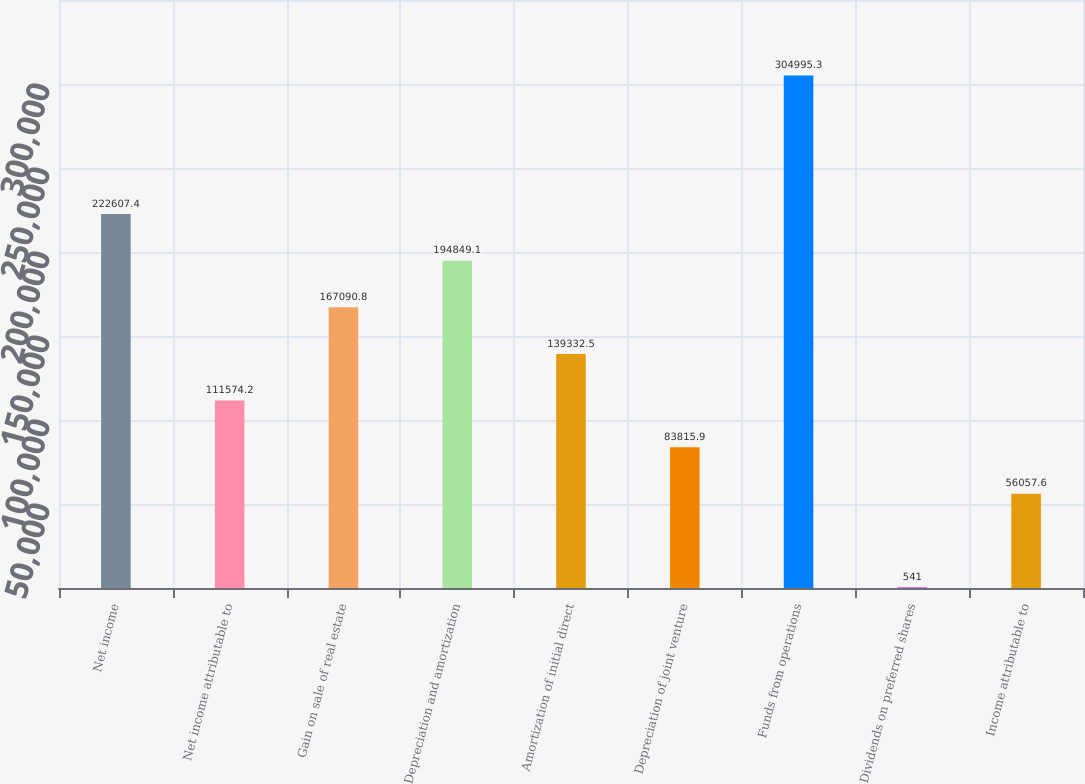Convert chart. <chart><loc_0><loc_0><loc_500><loc_500><bar_chart><fcel>Net income<fcel>Net income attributable to<fcel>Gain on sale of real estate<fcel>Depreciation and amortization<fcel>Amortization of initial direct<fcel>Depreciation of joint venture<fcel>Funds from operations<fcel>Dividends on preferred shares<fcel>Income attributable to<nl><fcel>222607<fcel>111574<fcel>167091<fcel>194849<fcel>139332<fcel>83815.9<fcel>304995<fcel>541<fcel>56057.6<nl></chart> 